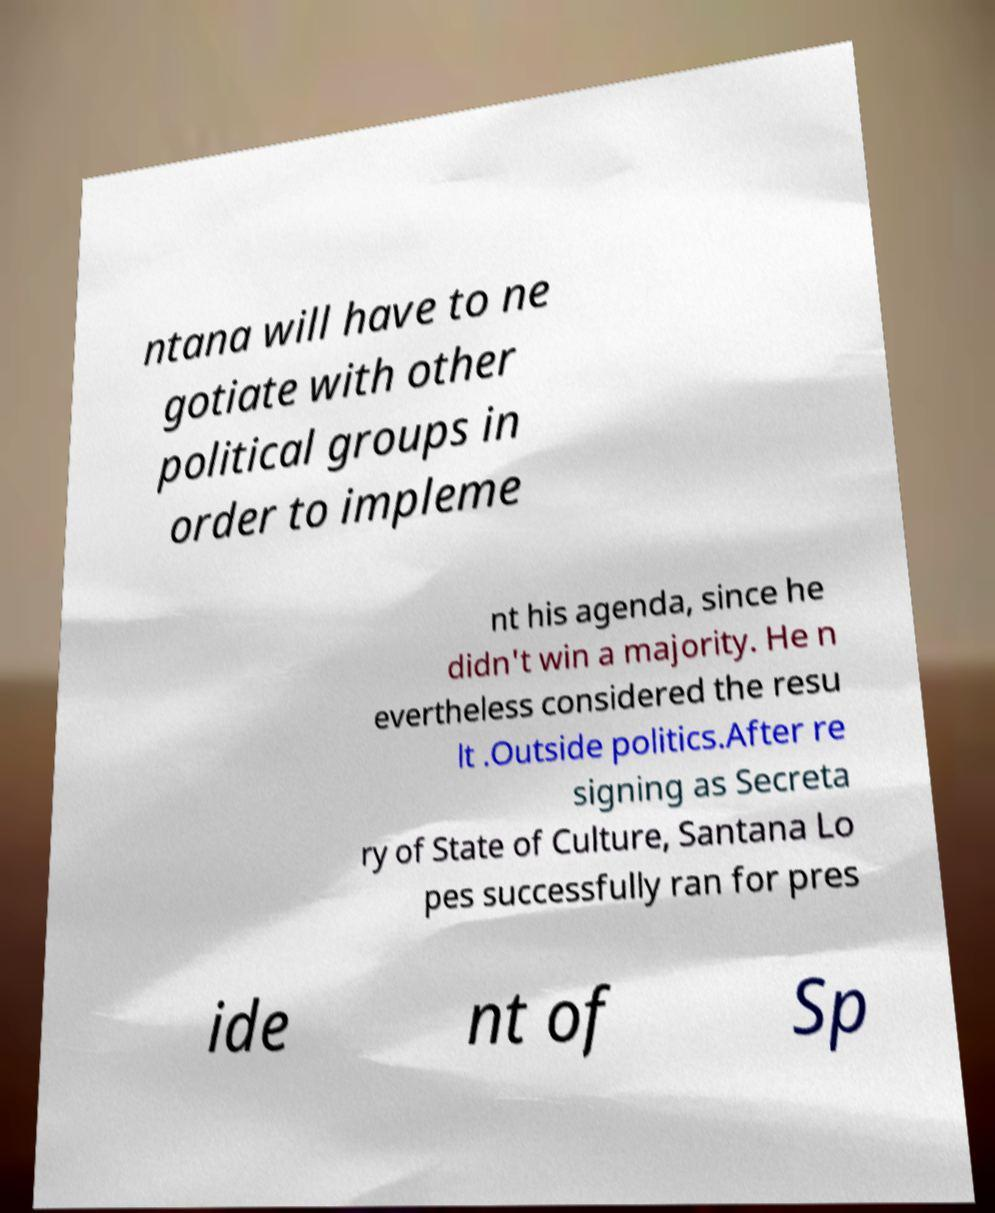Can you read and provide the text displayed in the image?This photo seems to have some interesting text. Can you extract and type it out for me? ntana will have to ne gotiate with other political groups in order to impleme nt his agenda, since he didn't win a majority. He n evertheless considered the resu lt .Outside politics.After re signing as Secreta ry of State of Culture, Santana Lo pes successfully ran for pres ide nt of Sp 